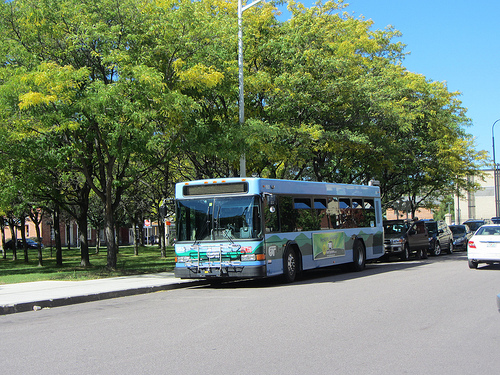On which side of the picture is the car? The car is located on the right side of the picture. 